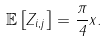Convert formula to latex. <formula><loc_0><loc_0><loc_500><loc_500>\mathbb { E } \left [ Z _ { i , j } \right ] = \frac { \pi } { 4 } \| x \| .</formula> 